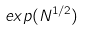Convert formula to latex. <formula><loc_0><loc_0><loc_500><loc_500>e x p ( N ^ { 1 / 2 } )</formula> 